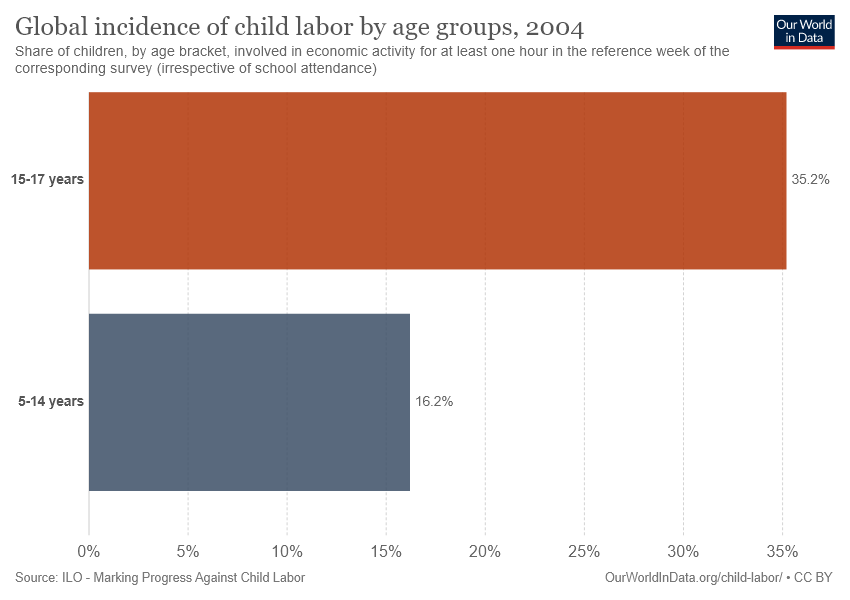Mention a couple of crucial points in this snapshot. Blue is the color that corresponds to the age range of 5 to 14 years. The percentage value for 15-17 year olds is 0.19, while the percentage value for 5-14 year olds is 0.20. 